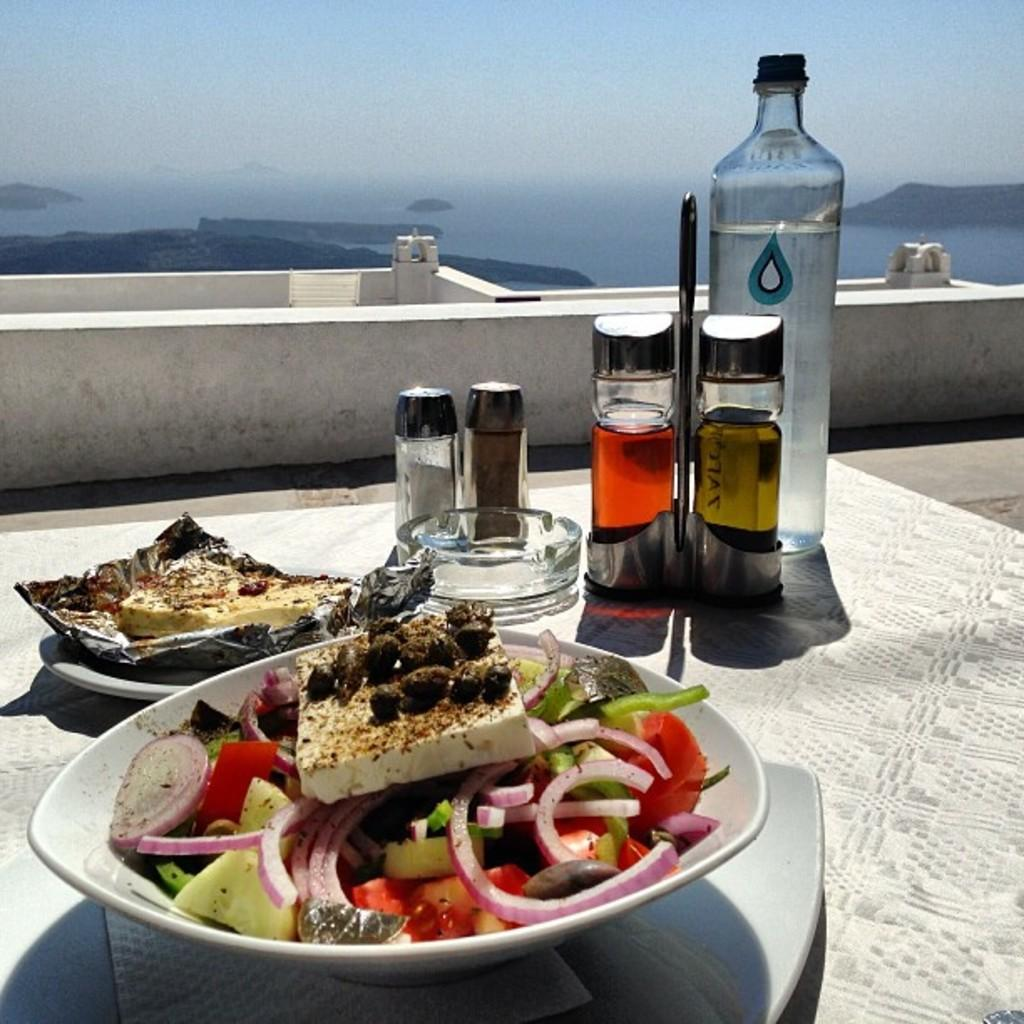What is on the plate that is visible in the image? There is a plate with food in the image. What other items can be seen on the table in the image? There is an ashtray and bottles visible on the table in the image. What can be seen in the background of the image? Water, mountains, and the sky are visible in the background of the image. What type of meat is being taxed in the image? There is no meat or taxation mentioned or depicted in the image. 